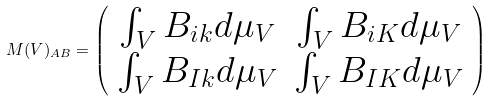<formula> <loc_0><loc_0><loc_500><loc_500>M ( V ) _ { A B } = \left ( \begin{array} { c c } \int _ { V } B _ { i k } d \mu _ { V } & \int _ { V } B _ { i K } d \mu _ { V } \\ \int _ { V } B _ { I k } d \mu _ { V } & \int _ { V } B _ { I K } d \mu _ { V } \end{array} \right )</formula> 